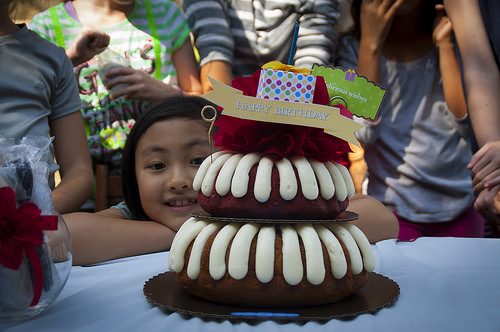<image>
Can you confirm if the children is on the table? No. The children is not positioned on the table. They may be near each other, but the children is not supported by or resting on top of the table. Where is the bottle in relation to the tablecloth? Is it behind the tablecloth? Yes. From this viewpoint, the bottle is positioned behind the tablecloth, with the tablecloth partially or fully occluding the bottle. 